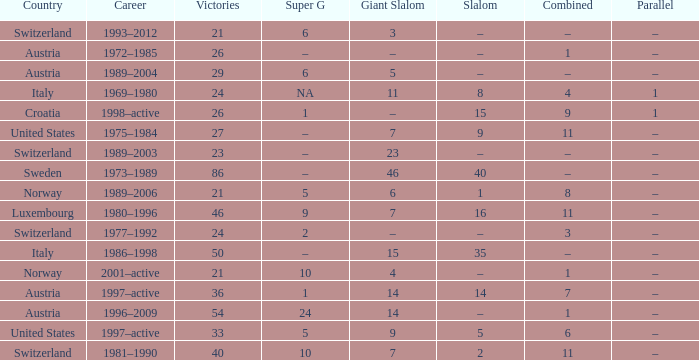What Super G has a Career of 1980–1996? 9.0. 